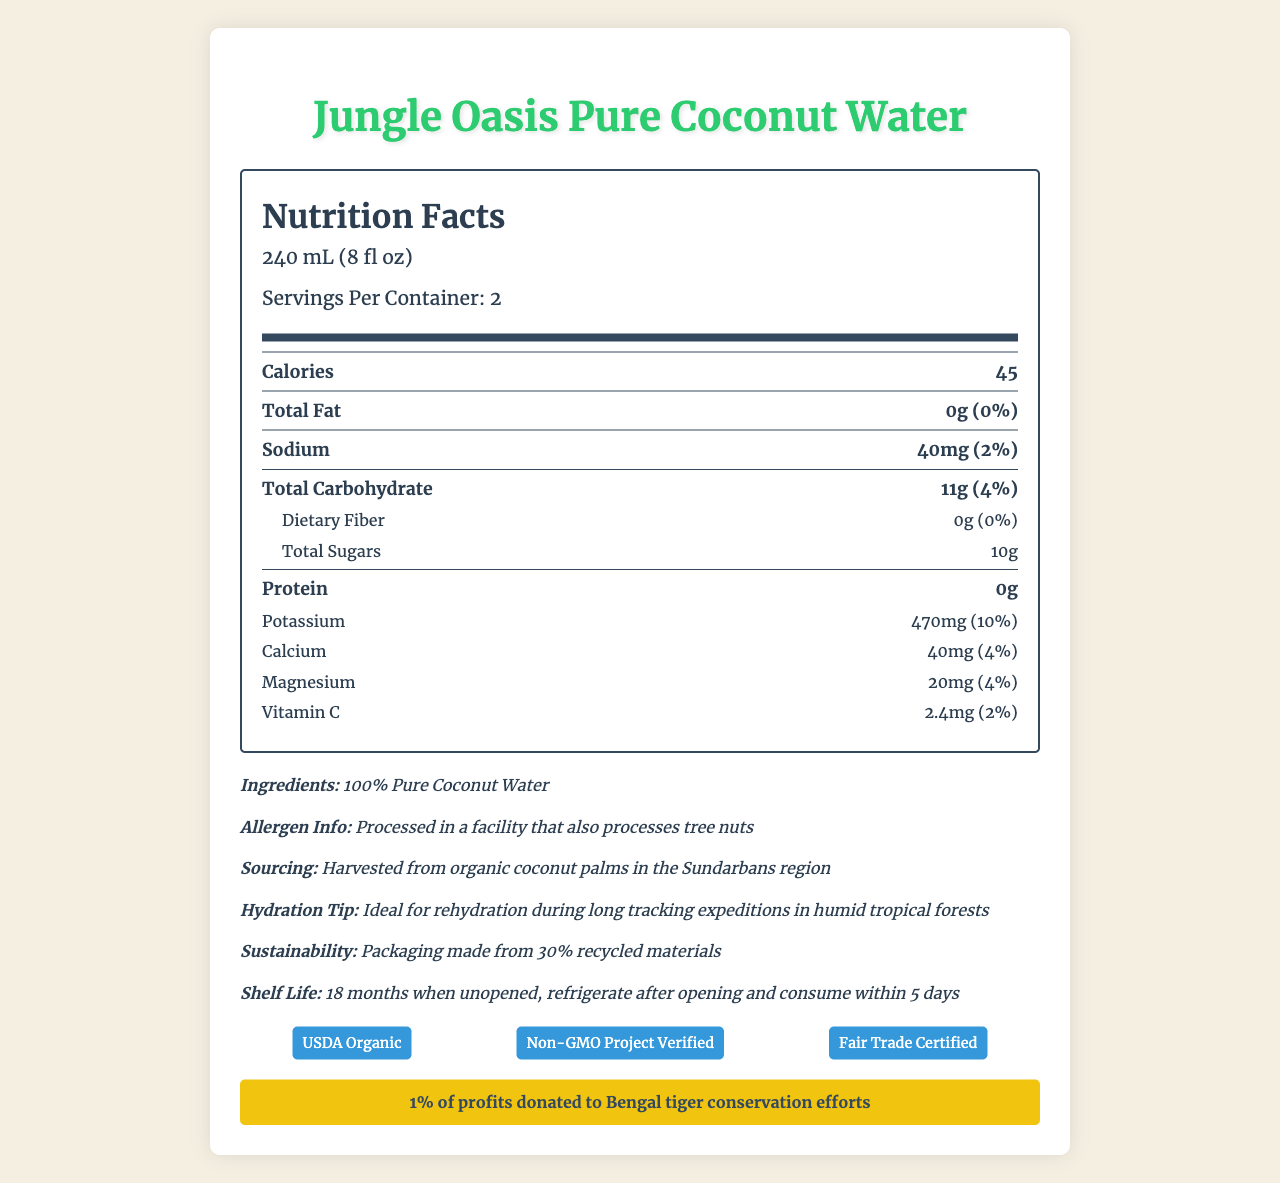what is the serving size? The document specifies the serving size as 240 mL (8 fl oz).
Answer: 240 mL (8 fl oz) how many calories are in one serving? The document states that there are 45 calories per serving.
Answer: 45 what is the amount of total fat per serving? The total fat per serving is listed as 0g.
Answer: 0g what is the sodium content per serving? The sodium content per serving is indicated as 40mg.
Answer: 40mg what is the potassium content per serving? The document mentions that there are 470mg of potassium per serving.
Answer: 470mg what ingredients are used in this coconut water? The ingredients listed are 100% Pure Coconut Water.
Answer: 100% Pure Coconut Water how long is the shelf life when unopened? The document states that the shelf life when unopened is 18 months.
Answer: 18 months what is the main nutrient contributing to the carbohydrates in this coconut water? The document shows that out of the total carbohydrates, a significant portion is from total sugars (10g).
Answer: Total Sugars how should you store the product after opening? It specifies that after opening, the product should be refrigerated and consumed within 5 days.
Answer: Refrigerate and consume within 5 days what certifications does this product have? The document lists three certifications: USDA Organic, Non-GMO Project Verified, and Fair Trade Certified.
Answer: USDA Organic, Non-GMO Project Verified, Fair Trade Certified how much of the profits are donated to Bengal tiger conservation efforts? The document mentions that 1% of profits are donated to Bengal tiger conservation efforts.
Answer: 1% which of the following nutrients is not present in Jungle Oasis Pure Coconut Water? 
A. Dietary Fiber
B. Protein
C. Potassium
D. Vitamin D The document lists the amounts of dietary fiber, protein, and potassium but does not mention Vitamin D.
Answer: D which is the correct sodium daily value percentage per serving?
I. 1%
II. 2%
III. 3%
IV. 4% The document shows that the daily value percentage for sodium per serving is 2%.
Answer: II is the product suitable for individuals with tree nut allergies? The document mentions that it is processed in a facility that also processes tree nuts, which could pose a risk for individuals with tree nut allergies.
Answer: No summarize the nutrition facts and other key details about Jungle Oasis Pure Coconut Water. This summary includes a detailed overview of nutrient content, ingredient information, recommendations for use, sustainability notes, conservation efforts, certifications, and storage instructions.
Answer: Jungle Oasis Pure Coconut Water is an organic product with zero fat, 45 calories per 240 mL serving, and contains 40mg of sodium, 11g of carbohydrates, 10g of sugars, 0g of protein, 470mg of potassium, 40mg of calcium, 20mg of magnesium, and 2.4mg of vitamin C. It is made from 100% Pure Coconut Water, processed in a facility that also handles tree nuts. It is harvested from organic coconut palms in the Sundarbans region and is recommended for hydration during long tracking expeditions in humid tropical forests. The packaging is 30% recycled, and 1% of profits are donated to Bengal tiger conservation efforts. The product is USDA Organic, Non-GMO Project Verified, and Fair Trade Certified, with a shelf life of 18 months when unopened. After opening, it should be refrigerated and consumed within 5 days. how much vitamin B12 does Jungle Oasis Pure Coconut Water contain? The document does not provide any information on the vitamin B12 content in Jungle Oasis Pure Coconut Water.
Answer: Not enough information 